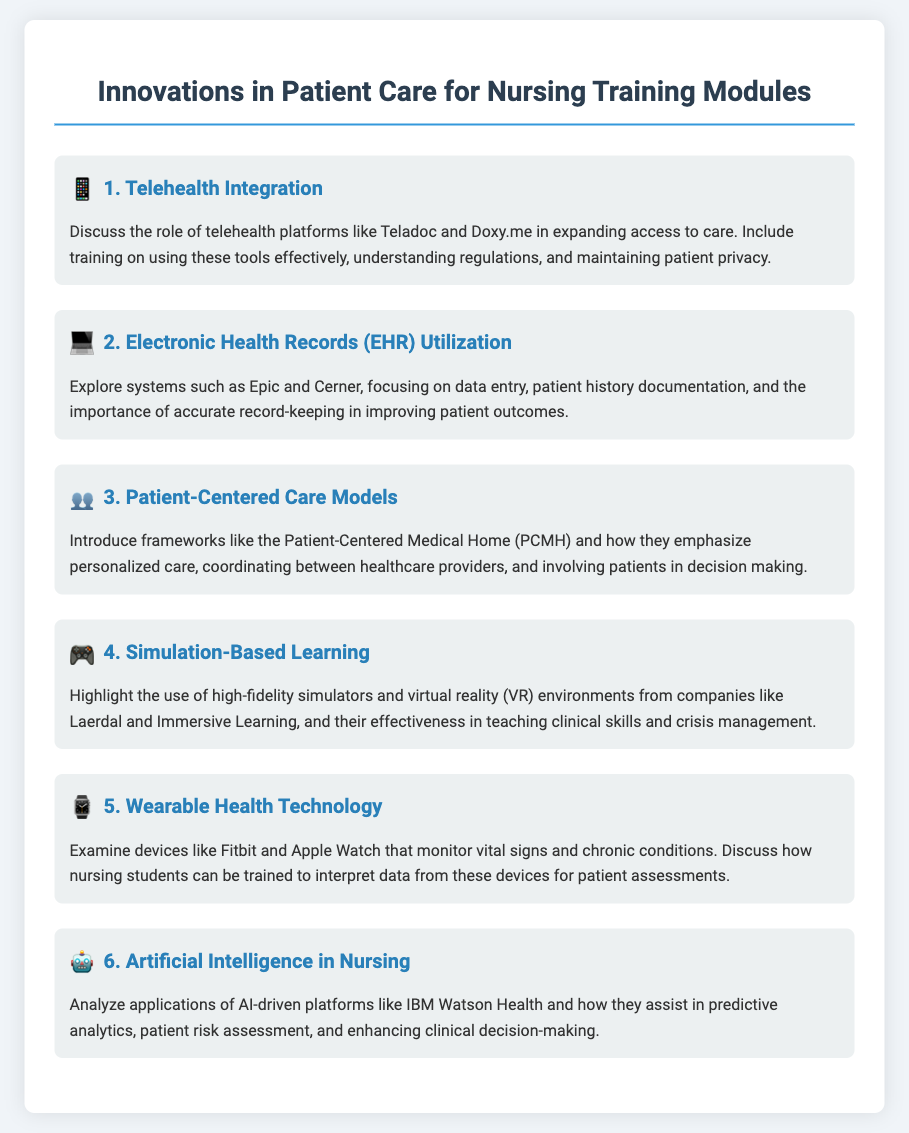What is the first topic discussed? The first topic in the document is Telehealth Integration, which focuses on the role of telehealth platforms in expanding access to care.
Answer: Telehealth Integration Which platform is mentioned for Electronic Health Records? The document mentions systems like Epic and Cerner in relation to Electronic Health Records utilization.
Answer: Epic and Cerner What learning method is highlighted for teaching clinical skills? The document highlights Simulation-Based Learning using high-fidelity simulators and virtual reality environments.
Answer: Simulation-Based Learning What technology is examined for monitoring vital signs? The document examines wearable health technology, specifically devices like Fitbit and Apple Watch for monitoring vital signs and chronic conditions.
Answer: Fitbit and Apple Watch Which AI platform is analyzed in the document? The document analyzes IBM Watson Health as an AI-driven platform in nursing.
Answer: IBM Watson Health What type of care models are introduced? The document introduces Patient-Centered Care Models, specifically the Patient-Centered Medical Home.
Answer: Patient-Centered Medical Home How does the document characterize simulation-based learning? It characterizes simulation-based learning as effective in teaching clinical skills and crisis management.
Answer: Effective in teaching clinical skills and crisis management 